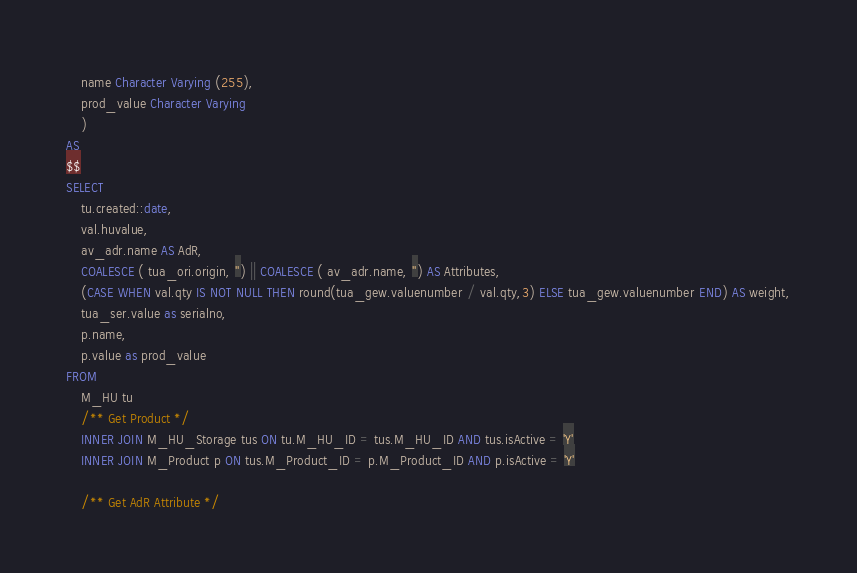<code> <loc_0><loc_0><loc_500><loc_500><_SQL_>	name Character Varying (255),
	prod_value Character Varying
	)
AS 
$$
SELECT
	tu.created::date,
	val.huvalue,
	av_adr.name AS AdR,
	COALESCE ( tua_ori.origin, '') || COALESCE ( av_adr.name, '') AS Attributes,
	(CASE WHEN val.qty IS NOT NULL THEN round(tua_gew.valuenumber / val.qty,3) ELSE tua_gew.valuenumber END) AS weight,
	tua_ser.value as serialno,
	p.name,
	p.value as prod_value
FROM
	M_HU tu
	/** Get Product */
	INNER JOIN M_HU_Storage tus ON tu.M_HU_ID = tus.M_HU_ID AND tus.isActive = 'Y'
	INNER JOIN M_Product p ON tus.M_Product_ID = p.M_Product_ID AND p.isActive = 'Y'

	/** Get AdR Attribute */</code> 